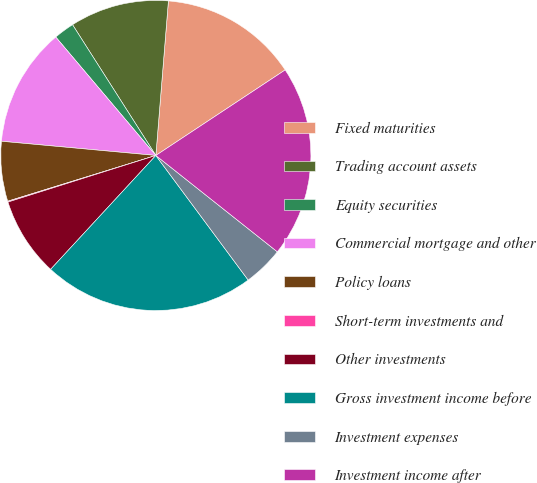Convert chart to OTSL. <chart><loc_0><loc_0><loc_500><loc_500><pie_chart><fcel>Fixed maturities<fcel>Trading account assets<fcel>Equity securities<fcel>Commercial mortgage and other<fcel>Policy loans<fcel>Short-term investments and<fcel>Other investments<fcel>Gross investment income before<fcel>Investment expenses<fcel>Investment income after<nl><fcel>14.41%<fcel>10.32%<fcel>2.14%<fcel>12.37%<fcel>6.23%<fcel>0.09%<fcel>8.27%<fcel>22.02%<fcel>4.18%<fcel>19.97%<nl></chart> 